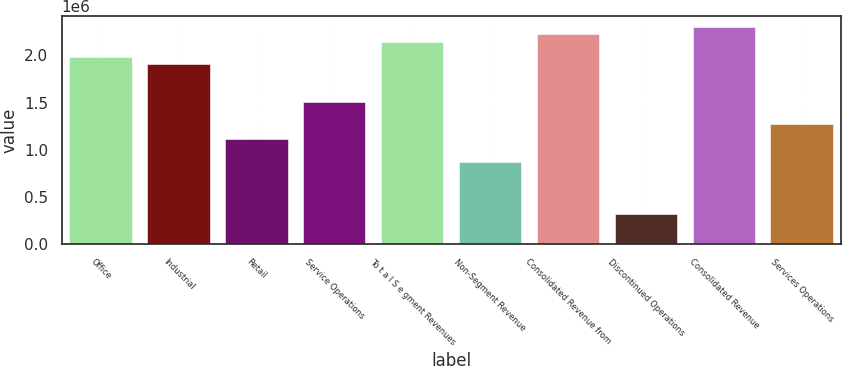<chart> <loc_0><loc_0><loc_500><loc_500><bar_chart><fcel>Office<fcel>Industrial<fcel>Retail<fcel>Service Operations<fcel>To t a l S e gment Revenues<fcel>Non-Segment Revenue<fcel>Consolidated Revenue from<fcel>Discontinued Operations<fcel>Consolidated Revenue<fcel>Services Operations<nl><fcel>1.98496e+06<fcel>1.9056e+06<fcel>1.11205e+06<fcel>1.50883e+06<fcel>2.14367e+06<fcel>873981<fcel>2.22303e+06<fcel>318491<fcel>2.30238e+06<fcel>1.27076e+06<nl></chart> 